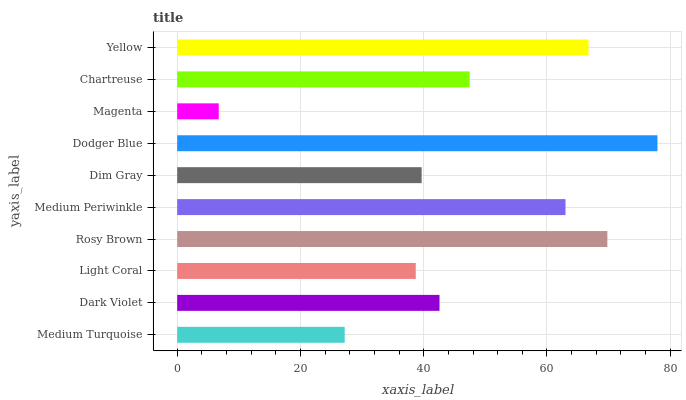Is Magenta the minimum?
Answer yes or no. Yes. Is Dodger Blue the maximum?
Answer yes or no. Yes. Is Dark Violet the minimum?
Answer yes or no. No. Is Dark Violet the maximum?
Answer yes or no. No. Is Dark Violet greater than Medium Turquoise?
Answer yes or no. Yes. Is Medium Turquoise less than Dark Violet?
Answer yes or no. Yes. Is Medium Turquoise greater than Dark Violet?
Answer yes or no. No. Is Dark Violet less than Medium Turquoise?
Answer yes or no. No. Is Chartreuse the high median?
Answer yes or no. Yes. Is Dark Violet the low median?
Answer yes or no. Yes. Is Dark Violet the high median?
Answer yes or no. No. Is Chartreuse the low median?
Answer yes or no. No. 